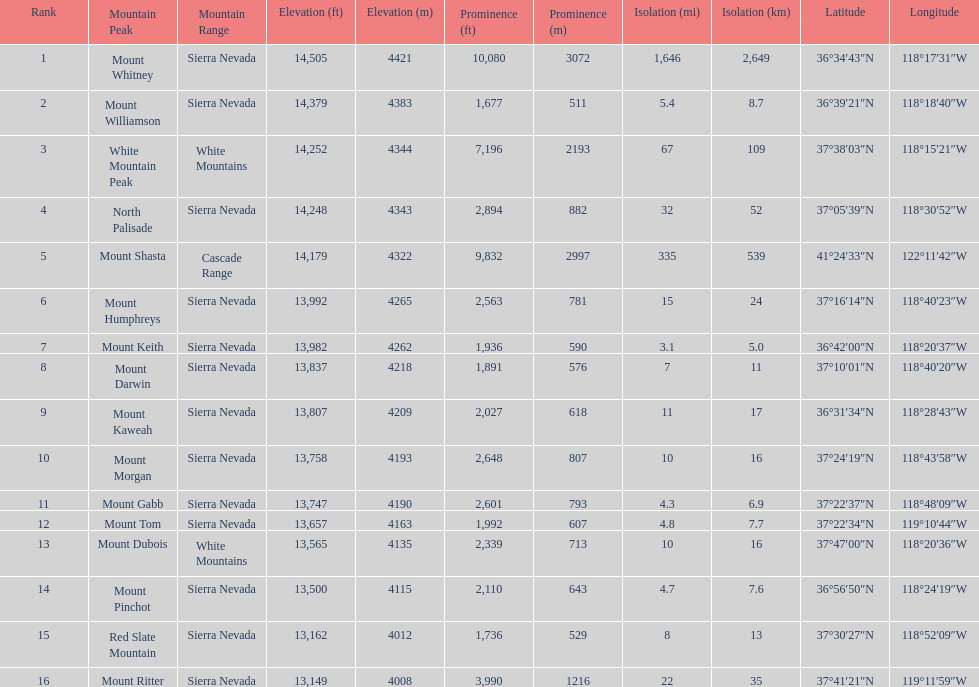How much taller is the mountain peak of mount williamson than that of mount keith? 397 ft. 